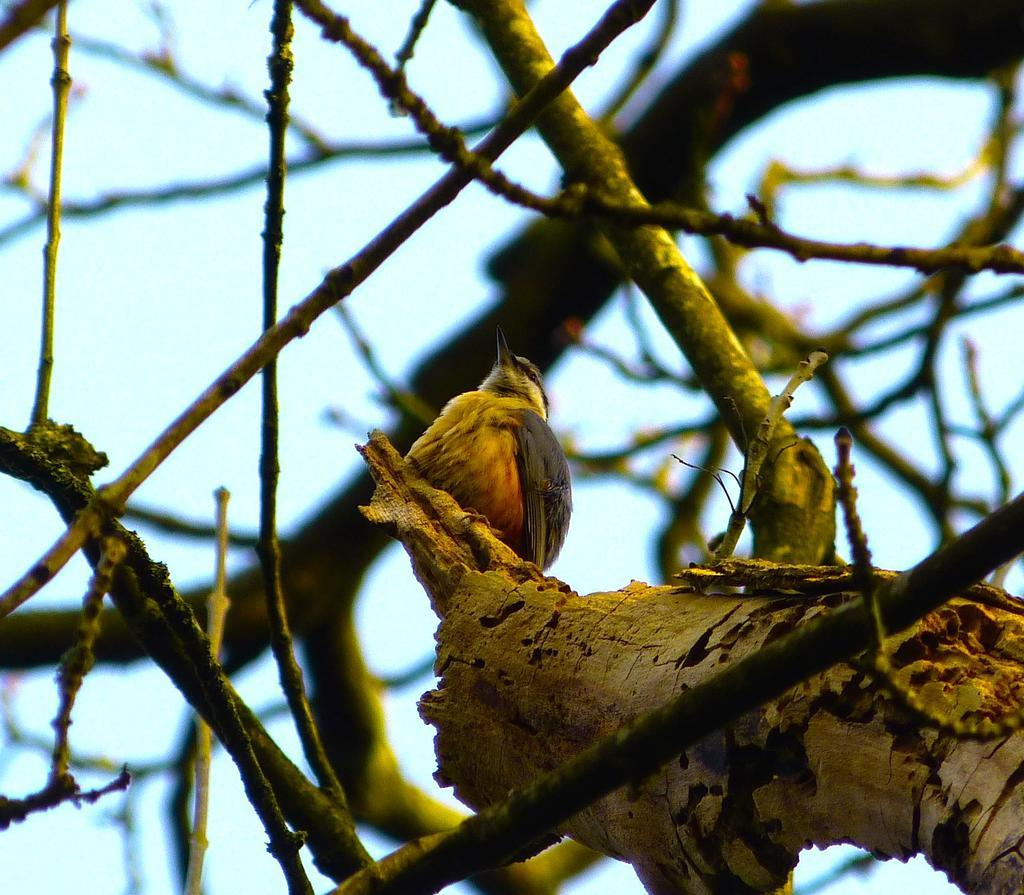What type of animal can be seen in the image? There is a bird in the image. Where is the bird located? The bird is on a tree. Can you see any caves or fairies near the bird in the image? There are no caves or fairies present in the image; it only features a bird on a tree. 